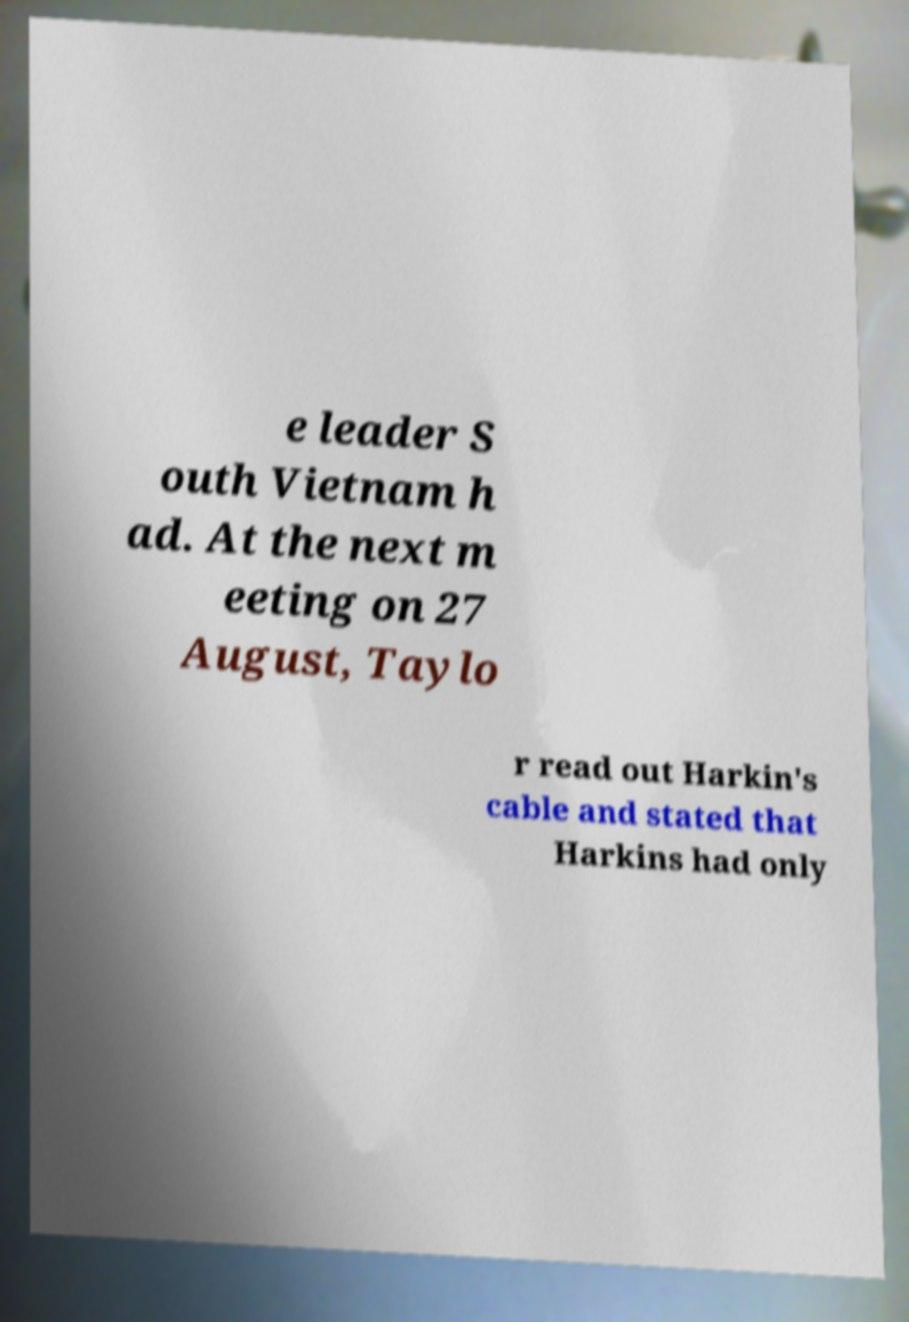Can you accurately transcribe the text from the provided image for me? e leader S outh Vietnam h ad. At the next m eeting on 27 August, Taylo r read out Harkin's cable and stated that Harkins had only 